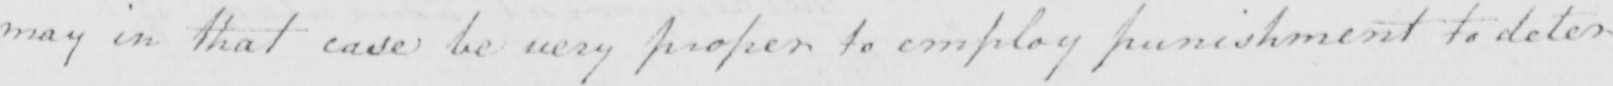Can you tell me what this handwritten text says? may in that case be very proper to employ punishment to deter 